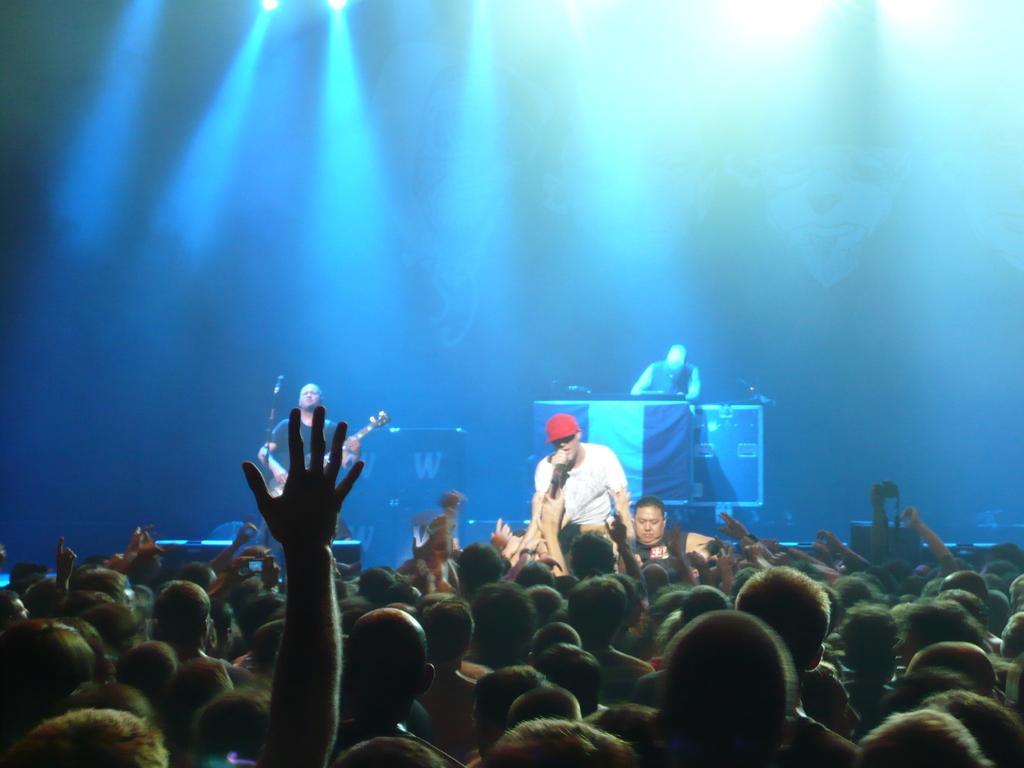Describe this image in one or two sentences. In the foreground of this picture, there is a crowd. In the background, there is a man holding a mic in his hand and another two men playing a musical instrument. On the top, there are lights. 